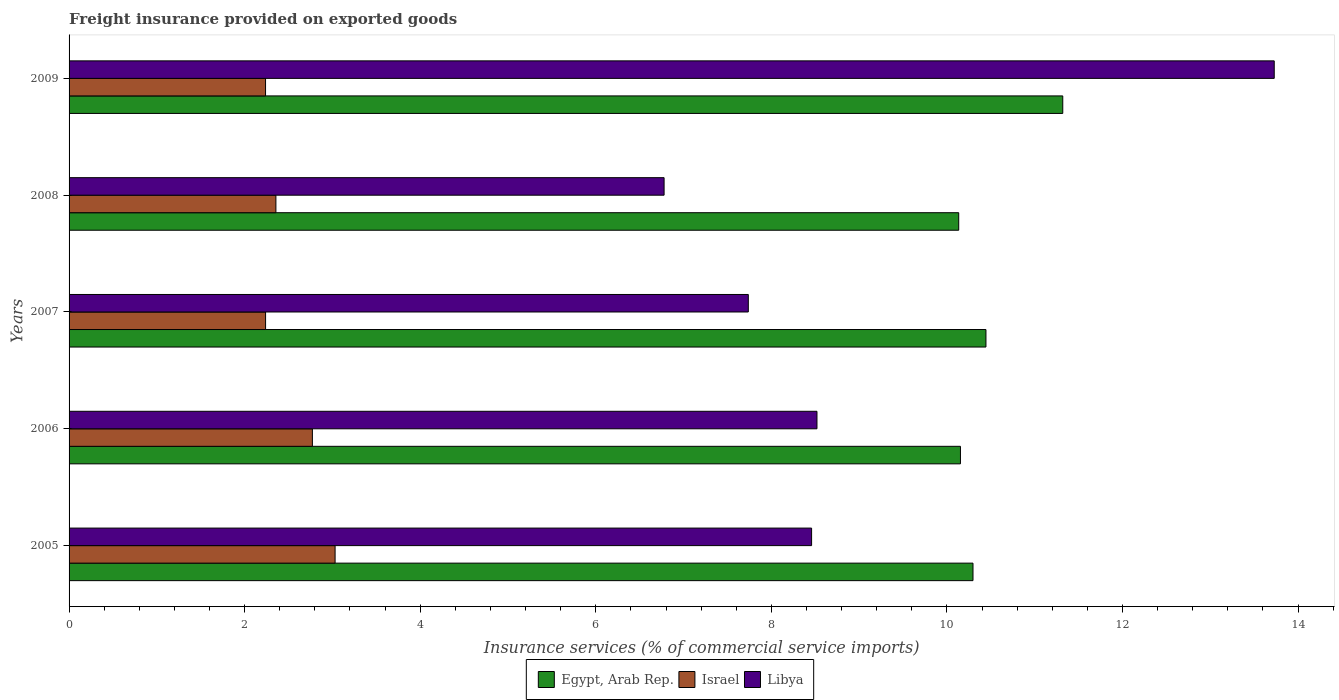How many different coloured bars are there?
Provide a succinct answer. 3. Are the number of bars per tick equal to the number of legend labels?
Make the answer very short. Yes. How many bars are there on the 4th tick from the top?
Your answer should be compact. 3. What is the label of the 1st group of bars from the top?
Your answer should be compact. 2009. What is the freight insurance provided on exported goods in Libya in 2006?
Your answer should be very brief. 8.52. Across all years, what is the maximum freight insurance provided on exported goods in Egypt, Arab Rep.?
Ensure brevity in your answer.  11.32. Across all years, what is the minimum freight insurance provided on exported goods in Egypt, Arab Rep.?
Provide a short and direct response. 10.13. In which year was the freight insurance provided on exported goods in Egypt, Arab Rep. maximum?
Provide a succinct answer. 2009. What is the total freight insurance provided on exported goods in Libya in the graph?
Your answer should be very brief. 45.22. What is the difference between the freight insurance provided on exported goods in Libya in 2005 and that in 2008?
Your response must be concise. 1.68. What is the difference between the freight insurance provided on exported goods in Egypt, Arab Rep. in 2009 and the freight insurance provided on exported goods in Israel in 2008?
Offer a very short reply. 8.96. What is the average freight insurance provided on exported goods in Israel per year?
Offer a very short reply. 2.53. In the year 2005, what is the difference between the freight insurance provided on exported goods in Israel and freight insurance provided on exported goods in Libya?
Your response must be concise. -5.43. What is the ratio of the freight insurance provided on exported goods in Egypt, Arab Rep. in 2005 to that in 2006?
Make the answer very short. 1.01. Is the freight insurance provided on exported goods in Egypt, Arab Rep. in 2005 less than that in 2007?
Your answer should be compact. Yes. What is the difference between the highest and the second highest freight insurance provided on exported goods in Egypt, Arab Rep.?
Keep it short and to the point. 0.88. What is the difference between the highest and the lowest freight insurance provided on exported goods in Israel?
Offer a terse response. 0.79. In how many years, is the freight insurance provided on exported goods in Israel greater than the average freight insurance provided on exported goods in Israel taken over all years?
Give a very brief answer. 2. Is the sum of the freight insurance provided on exported goods in Libya in 2007 and 2009 greater than the maximum freight insurance provided on exported goods in Israel across all years?
Your response must be concise. Yes. What does the 2nd bar from the top in 2008 represents?
Offer a very short reply. Israel. What does the 3rd bar from the bottom in 2008 represents?
Offer a terse response. Libya. Is it the case that in every year, the sum of the freight insurance provided on exported goods in Libya and freight insurance provided on exported goods in Egypt, Arab Rep. is greater than the freight insurance provided on exported goods in Israel?
Your answer should be compact. Yes. How many bars are there?
Give a very brief answer. 15. What is the difference between two consecutive major ticks on the X-axis?
Keep it short and to the point. 2. Does the graph contain any zero values?
Your response must be concise. No. Does the graph contain grids?
Ensure brevity in your answer.  No. Where does the legend appear in the graph?
Your response must be concise. Bottom center. How are the legend labels stacked?
Give a very brief answer. Horizontal. What is the title of the graph?
Offer a very short reply. Freight insurance provided on exported goods. Does "Tajikistan" appear as one of the legend labels in the graph?
Provide a short and direct response. No. What is the label or title of the X-axis?
Provide a succinct answer. Insurance services (% of commercial service imports). What is the label or title of the Y-axis?
Provide a succinct answer. Years. What is the Insurance services (% of commercial service imports) of Egypt, Arab Rep. in 2005?
Give a very brief answer. 10.3. What is the Insurance services (% of commercial service imports) of Israel in 2005?
Make the answer very short. 3.03. What is the Insurance services (% of commercial service imports) of Libya in 2005?
Give a very brief answer. 8.46. What is the Insurance services (% of commercial service imports) of Egypt, Arab Rep. in 2006?
Offer a very short reply. 10.15. What is the Insurance services (% of commercial service imports) in Israel in 2006?
Provide a short and direct response. 2.77. What is the Insurance services (% of commercial service imports) in Libya in 2006?
Provide a short and direct response. 8.52. What is the Insurance services (% of commercial service imports) of Egypt, Arab Rep. in 2007?
Your answer should be compact. 10.44. What is the Insurance services (% of commercial service imports) of Israel in 2007?
Give a very brief answer. 2.24. What is the Insurance services (% of commercial service imports) in Libya in 2007?
Provide a short and direct response. 7.74. What is the Insurance services (% of commercial service imports) in Egypt, Arab Rep. in 2008?
Your response must be concise. 10.13. What is the Insurance services (% of commercial service imports) in Israel in 2008?
Your response must be concise. 2.36. What is the Insurance services (% of commercial service imports) in Libya in 2008?
Provide a short and direct response. 6.78. What is the Insurance services (% of commercial service imports) of Egypt, Arab Rep. in 2009?
Your answer should be compact. 11.32. What is the Insurance services (% of commercial service imports) of Israel in 2009?
Provide a succinct answer. 2.24. What is the Insurance services (% of commercial service imports) in Libya in 2009?
Provide a succinct answer. 13.73. Across all years, what is the maximum Insurance services (% of commercial service imports) of Egypt, Arab Rep.?
Your answer should be compact. 11.32. Across all years, what is the maximum Insurance services (% of commercial service imports) in Israel?
Provide a succinct answer. 3.03. Across all years, what is the maximum Insurance services (% of commercial service imports) in Libya?
Offer a very short reply. 13.73. Across all years, what is the minimum Insurance services (% of commercial service imports) of Egypt, Arab Rep.?
Your answer should be compact. 10.13. Across all years, what is the minimum Insurance services (% of commercial service imports) of Israel?
Ensure brevity in your answer.  2.24. Across all years, what is the minimum Insurance services (% of commercial service imports) in Libya?
Offer a terse response. 6.78. What is the total Insurance services (% of commercial service imports) of Egypt, Arab Rep. in the graph?
Your response must be concise. 52.35. What is the total Insurance services (% of commercial service imports) in Israel in the graph?
Offer a very short reply. 12.64. What is the total Insurance services (% of commercial service imports) in Libya in the graph?
Provide a short and direct response. 45.22. What is the difference between the Insurance services (% of commercial service imports) of Egypt, Arab Rep. in 2005 and that in 2006?
Your answer should be compact. 0.14. What is the difference between the Insurance services (% of commercial service imports) of Israel in 2005 and that in 2006?
Offer a terse response. 0.26. What is the difference between the Insurance services (% of commercial service imports) in Libya in 2005 and that in 2006?
Offer a very short reply. -0.06. What is the difference between the Insurance services (% of commercial service imports) in Egypt, Arab Rep. in 2005 and that in 2007?
Offer a very short reply. -0.15. What is the difference between the Insurance services (% of commercial service imports) of Israel in 2005 and that in 2007?
Make the answer very short. 0.79. What is the difference between the Insurance services (% of commercial service imports) in Libya in 2005 and that in 2007?
Your answer should be very brief. 0.72. What is the difference between the Insurance services (% of commercial service imports) of Egypt, Arab Rep. in 2005 and that in 2008?
Your response must be concise. 0.16. What is the difference between the Insurance services (% of commercial service imports) of Israel in 2005 and that in 2008?
Your answer should be compact. 0.67. What is the difference between the Insurance services (% of commercial service imports) in Libya in 2005 and that in 2008?
Your response must be concise. 1.68. What is the difference between the Insurance services (% of commercial service imports) of Egypt, Arab Rep. in 2005 and that in 2009?
Provide a short and direct response. -1.02. What is the difference between the Insurance services (% of commercial service imports) in Israel in 2005 and that in 2009?
Offer a terse response. 0.79. What is the difference between the Insurance services (% of commercial service imports) in Libya in 2005 and that in 2009?
Provide a short and direct response. -5.27. What is the difference between the Insurance services (% of commercial service imports) of Egypt, Arab Rep. in 2006 and that in 2007?
Your response must be concise. -0.29. What is the difference between the Insurance services (% of commercial service imports) in Israel in 2006 and that in 2007?
Provide a succinct answer. 0.53. What is the difference between the Insurance services (% of commercial service imports) of Libya in 2006 and that in 2007?
Make the answer very short. 0.78. What is the difference between the Insurance services (% of commercial service imports) of Egypt, Arab Rep. in 2006 and that in 2008?
Provide a succinct answer. 0.02. What is the difference between the Insurance services (% of commercial service imports) of Israel in 2006 and that in 2008?
Provide a succinct answer. 0.42. What is the difference between the Insurance services (% of commercial service imports) in Libya in 2006 and that in 2008?
Your answer should be very brief. 1.74. What is the difference between the Insurance services (% of commercial service imports) in Egypt, Arab Rep. in 2006 and that in 2009?
Ensure brevity in your answer.  -1.17. What is the difference between the Insurance services (% of commercial service imports) in Israel in 2006 and that in 2009?
Provide a succinct answer. 0.53. What is the difference between the Insurance services (% of commercial service imports) in Libya in 2006 and that in 2009?
Your answer should be very brief. -5.21. What is the difference between the Insurance services (% of commercial service imports) of Egypt, Arab Rep. in 2007 and that in 2008?
Make the answer very short. 0.31. What is the difference between the Insurance services (% of commercial service imports) in Israel in 2007 and that in 2008?
Provide a succinct answer. -0.12. What is the difference between the Insurance services (% of commercial service imports) of Libya in 2007 and that in 2008?
Provide a short and direct response. 0.96. What is the difference between the Insurance services (% of commercial service imports) of Egypt, Arab Rep. in 2007 and that in 2009?
Your response must be concise. -0.88. What is the difference between the Insurance services (% of commercial service imports) of Israel in 2007 and that in 2009?
Your answer should be compact. 0. What is the difference between the Insurance services (% of commercial service imports) in Libya in 2007 and that in 2009?
Keep it short and to the point. -5.99. What is the difference between the Insurance services (% of commercial service imports) of Egypt, Arab Rep. in 2008 and that in 2009?
Your answer should be compact. -1.19. What is the difference between the Insurance services (% of commercial service imports) in Israel in 2008 and that in 2009?
Make the answer very short. 0.12. What is the difference between the Insurance services (% of commercial service imports) in Libya in 2008 and that in 2009?
Your answer should be compact. -6.95. What is the difference between the Insurance services (% of commercial service imports) of Egypt, Arab Rep. in 2005 and the Insurance services (% of commercial service imports) of Israel in 2006?
Your response must be concise. 7.53. What is the difference between the Insurance services (% of commercial service imports) of Egypt, Arab Rep. in 2005 and the Insurance services (% of commercial service imports) of Libya in 2006?
Make the answer very short. 1.78. What is the difference between the Insurance services (% of commercial service imports) of Israel in 2005 and the Insurance services (% of commercial service imports) of Libya in 2006?
Keep it short and to the point. -5.49. What is the difference between the Insurance services (% of commercial service imports) in Egypt, Arab Rep. in 2005 and the Insurance services (% of commercial service imports) in Israel in 2007?
Give a very brief answer. 8.06. What is the difference between the Insurance services (% of commercial service imports) in Egypt, Arab Rep. in 2005 and the Insurance services (% of commercial service imports) in Libya in 2007?
Ensure brevity in your answer.  2.56. What is the difference between the Insurance services (% of commercial service imports) of Israel in 2005 and the Insurance services (% of commercial service imports) of Libya in 2007?
Make the answer very short. -4.71. What is the difference between the Insurance services (% of commercial service imports) in Egypt, Arab Rep. in 2005 and the Insurance services (% of commercial service imports) in Israel in 2008?
Offer a terse response. 7.94. What is the difference between the Insurance services (% of commercial service imports) in Egypt, Arab Rep. in 2005 and the Insurance services (% of commercial service imports) in Libya in 2008?
Give a very brief answer. 3.52. What is the difference between the Insurance services (% of commercial service imports) of Israel in 2005 and the Insurance services (% of commercial service imports) of Libya in 2008?
Your answer should be compact. -3.75. What is the difference between the Insurance services (% of commercial service imports) of Egypt, Arab Rep. in 2005 and the Insurance services (% of commercial service imports) of Israel in 2009?
Provide a succinct answer. 8.06. What is the difference between the Insurance services (% of commercial service imports) in Egypt, Arab Rep. in 2005 and the Insurance services (% of commercial service imports) in Libya in 2009?
Make the answer very short. -3.43. What is the difference between the Insurance services (% of commercial service imports) in Israel in 2005 and the Insurance services (% of commercial service imports) in Libya in 2009?
Offer a terse response. -10.7. What is the difference between the Insurance services (% of commercial service imports) of Egypt, Arab Rep. in 2006 and the Insurance services (% of commercial service imports) of Israel in 2007?
Your response must be concise. 7.92. What is the difference between the Insurance services (% of commercial service imports) in Egypt, Arab Rep. in 2006 and the Insurance services (% of commercial service imports) in Libya in 2007?
Your answer should be very brief. 2.42. What is the difference between the Insurance services (% of commercial service imports) of Israel in 2006 and the Insurance services (% of commercial service imports) of Libya in 2007?
Keep it short and to the point. -4.97. What is the difference between the Insurance services (% of commercial service imports) in Egypt, Arab Rep. in 2006 and the Insurance services (% of commercial service imports) in Israel in 2008?
Your answer should be compact. 7.8. What is the difference between the Insurance services (% of commercial service imports) of Egypt, Arab Rep. in 2006 and the Insurance services (% of commercial service imports) of Libya in 2008?
Provide a short and direct response. 3.38. What is the difference between the Insurance services (% of commercial service imports) in Israel in 2006 and the Insurance services (% of commercial service imports) in Libya in 2008?
Offer a very short reply. -4.01. What is the difference between the Insurance services (% of commercial service imports) in Egypt, Arab Rep. in 2006 and the Insurance services (% of commercial service imports) in Israel in 2009?
Offer a terse response. 7.92. What is the difference between the Insurance services (% of commercial service imports) in Egypt, Arab Rep. in 2006 and the Insurance services (% of commercial service imports) in Libya in 2009?
Provide a succinct answer. -3.57. What is the difference between the Insurance services (% of commercial service imports) in Israel in 2006 and the Insurance services (% of commercial service imports) in Libya in 2009?
Keep it short and to the point. -10.96. What is the difference between the Insurance services (% of commercial service imports) in Egypt, Arab Rep. in 2007 and the Insurance services (% of commercial service imports) in Israel in 2008?
Ensure brevity in your answer.  8.09. What is the difference between the Insurance services (% of commercial service imports) of Egypt, Arab Rep. in 2007 and the Insurance services (% of commercial service imports) of Libya in 2008?
Provide a short and direct response. 3.67. What is the difference between the Insurance services (% of commercial service imports) in Israel in 2007 and the Insurance services (% of commercial service imports) in Libya in 2008?
Your response must be concise. -4.54. What is the difference between the Insurance services (% of commercial service imports) of Egypt, Arab Rep. in 2007 and the Insurance services (% of commercial service imports) of Israel in 2009?
Ensure brevity in your answer.  8.21. What is the difference between the Insurance services (% of commercial service imports) of Egypt, Arab Rep. in 2007 and the Insurance services (% of commercial service imports) of Libya in 2009?
Your answer should be very brief. -3.28. What is the difference between the Insurance services (% of commercial service imports) of Israel in 2007 and the Insurance services (% of commercial service imports) of Libya in 2009?
Provide a succinct answer. -11.49. What is the difference between the Insurance services (% of commercial service imports) in Egypt, Arab Rep. in 2008 and the Insurance services (% of commercial service imports) in Israel in 2009?
Provide a succinct answer. 7.9. What is the difference between the Insurance services (% of commercial service imports) in Egypt, Arab Rep. in 2008 and the Insurance services (% of commercial service imports) in Libya in 2009?
Give a very brief answer. -3.59. What is the difference between the Insurance services (% of commercial service imports) of Israel in 2008 and the Insurance services (% of commercial service imports) of Libya in 2009?
Give a very brief answer. -11.37. What is the average Insurance services (% of commercial service imports) of Egypt, Arab Rep. per year?
Your answer should be very brief. 10.47. What is the average Insurance services (% of commercial service imports) of Israel per year?
Provide a short and direct response. 2.53. What is the average Insurance services (% of commercial service imports) of Libya per year?
Provide a succinct answer. 9.04. In the year 2005, what is the difference between the Insurance services (% of commercial service imports) of Egypt, Arab Rep. and Insurance services (% of commercial service imports) of Israel?
Offer a very short reply. 7.27. In the year 2005, what is the difference between the Insurance services (% of commercial service imports) of Egypt, Arab Rep. and Insurance services (% of commercial service imports) of Libya?
Offer a terse response. 1.84. In the year 2005, what is the difference between the Insurance services (% of commercial service imports) in Israel and Insurance services (% of commercial service imports) in Libya?
Provide a short and direct response. -5.43. In the year 2006, what is the difference between the Insurance services (% of commercial service imports) in Egypt, Arab Rep. and Insurance services (% of commercial service imports) in Israel?
Keep it short and to the point. 7.38. In the year 2006, what is the difference between the Insurance services (% of commercial service imports) of Egypt, Arab Rep. and Insurance services (% of commercial service imports) of Libya?
Ensure brevity in your answer.  1.63. In the year 2006, what is the difference between the Insurance services (% of commercial service imports) in Israel and Insurance services (% of commercial service imports) in Libya?
Provide a short and direct response. -5.75. In the year 2007, what is the difference between the Insurance services (% of commercial service imports) in Egypt, Arab Rep. and Insurance services (% of commercial service imports) in Israel?
Make the answer very short. 8.21. In the year 2007, what is the difference between the Insurance services (% of commercial service imports) in Egypt, Arab Rep. and Insurance services (% of commercial service imports) in Libya?
Keep it short and to the point. 2.71. In the year 2007, what is the difference between the Insurance services (% of commercial service imports) in Israel and Insurance services (% of commercial service imports) in Libya?
Offer a terse response. -5.5. In the year 2008, what is the difference between the Insurance services (% of commercial service imports) of Egypt, Arab Rep. and Insurance services (% of commercial service imports) of Israel?
Make the answer very short. 7.78. In the year 2008, what is the difference between the Insurance services (% of commercial service imports) of Egypt, Arab Rep. and Insurance services (% of commercial service imports) of Libya?
Ensure brevity in your answer.  3.36. In the year 2008, what is the difference between the Insurance services (% of commercial service imports) of Israel and Insurance services (% of commercial service imports) of Libya?
Keep it short and to the point. -4.42. In the year 2009, what is the difference between the Insurance services (% of commercial service imports) of Egypt, Arab Rep. and Insurance services (% of commercial service imports) of Israel?
Ensure brevity in your answer.  9.08. In the year 2009, what is the difference between the Insurance services (% of commercial service imports) in Egypt, Arab Rep. and Insurance services (% of commercial service imports) in Libya?
Keep it short and to the point. -2.41. In the year 2009, what is the difference between the Insurance services (% of commercial service imports) in Israel and Insurance services (% of commercial service imports) in Libya?
Provide a short and direct response. -11.49. What is the ratio of the Insurance services (% of commercial service imports) of Egypt, Arab Rep. in 2005 to that in 2006?
Ensure brevity in your answer.  1.01. What is the ratio of the Insurance services (% of commercial service imports) of Israel in 2005 to that in 2006?
Provide a succinct answer. 1.09. What is the ratio of the Insurance services (% of commercial service imports) in Libya in 2005 to that in 2006?
Provide a succinct answer. 0.99. What is the ratio of the Insurance services (% of commercial service imports) in Egypt, Arab Rep. in 2005 to that in 2007?
Offer a terse response. 0.99. What is the ratio of the Insurance services (% of commercial service imports) in Israel in 2005 to that in 2007?
Offer a terse response. 1.35. What is the ratio of the Insurance services (% of commercial service imports) of Libya in 2005 to that in 2007?
Your response must be concise. 1.09. What is the ratio of the Insurance services (% of commercial service imports) in Israel in 2005 to that in 2008?
Give a very brief answer. 1.29. What is the ratio of the Insurance services (% of commercial service imports) in Libya in 2005 to that in 2008?
Provide a succinct answer. 1.25. What is the ratio of the Insurance services (% of commercial service imports) in Egypt, Arab Rep. in 2005 to that in 2009?
Ensure brevity in your answer.  0.91. What is the ratio of the Insurance services (% of commercial service imports) of Israel in 2005 to that in 2009?
Make the answer very short. 1.35. What is the ratio of the Insurance services (% of commercial service imports) in Libya in 2005 to that in 2009?
Ensure brevity in your answer.  0.62. What is the ratio of the Insurance services (% of commercial service imports) in Egypt, Arab Rep. in 2006 to that in 2007?
Make the answer very short. 0.97. What is the ratio of the Insurance services (% of commercial service imports) of Israel in 2006 to that in 2007?
Give a very brief answer. 1.24. What is the ratio of the Insurance services (% of commercial service imports) in Libya in 2006 to that in 2007?
Provide a short and direct response. 1.1. What is the ratio of the Insurance services (% of commercial service imports) of Egypt, Arab Rep. in 2006 to that in 2008?
Your answer should be very brief. 1. What is the ratio of the Insurance services (% of commercial service imports) of Israel in 2006 to that in 2008?
Ensure brevity in your answer.  1.18. What is the ratio of the Insurance services (% of commercial service imports) of Libya in 2006 to that in 2008?
Make the answer very short. 1.26. What is the ratio of the Insurance services (% of commercial service imports) in Egypt, Arab Rep. in 2006 to that in 2009?
Your answer should be compact. 0.9. What is the ratio of the Insurance services (% of commercial service imports) of Israel in 2006 to that in 2009?
Your answer should be very brief. 1.24. What is the ratio of the Insurance services (% of commercial service imports) of Libya in 2006 to that in 2009?
Provide a succinct answer. 0.62. What is the ratio of the Insurance services (% of commercial service imports) in Egypt, Arab Rep. in 2007 to that in 2008?
Offer a very short reply. 1.03. What is the ratio of the Insurance services (% of commercial service imports) of Israel in 2007 to that in 2008?
Your answer should be very brief. 0.95. What is the ratio of the Insurance services (% of commercial service imports) of Libya in 2007 to that in 2008?
Your answer should be compact. 1.14. What is the ratio of the Insurance services (% of commercial service imports) in Egypt, Arab Rep. in 2007 to that in 2009?
Your response must be concise. 0.92. What is the ratio of the Insurance services (% of commercial service imports) of Israel in 2007 to that in 2009?
Provide a succinct answer. 1. What is the ratio of the Insurance services (% of commercial service imports) in Libya in 2007 to that in 2009?
Your answer should be compact. 0.56. What is the ratio of the Insurance services (% of commercial service imports) of Egypt, Arab Rep. in 2008 to that in 2009?
Make the answer very short. 0.9. What is the ratio of the Insurance services (% of commercial service imports) in Israel in 2008 to that in 2009?
Offer a terse response. 1.05. What is the ratio of the Insurance services (% of commercial service imports) of Libya in 2008 to that in 2009?
Your response must be concise. 0.49. What is the difference between the highest and the second highest Insurance services (% of commercial service imports) in Israel?
Your answer should be compact. 0.26. What is the difference between the highest and the second highest Insurance services (% of commercial service imports) in Libya?
Your response must be concise. 5.21. What is the difference between the highest and the lowest Insurance services (% of commercial service imports) in Egypt, Arab Rep.?
Make the answer very short. 1.19. What is the difference between the highest and the lowest Insurance services (% of commercial service imports) of Israel?
Give a very brief answer. 0.79. What is the difference between the highest and the lowest Insurance services (% of commercial service imports) in Libya?
Provide a short and direct response. 6.95. 